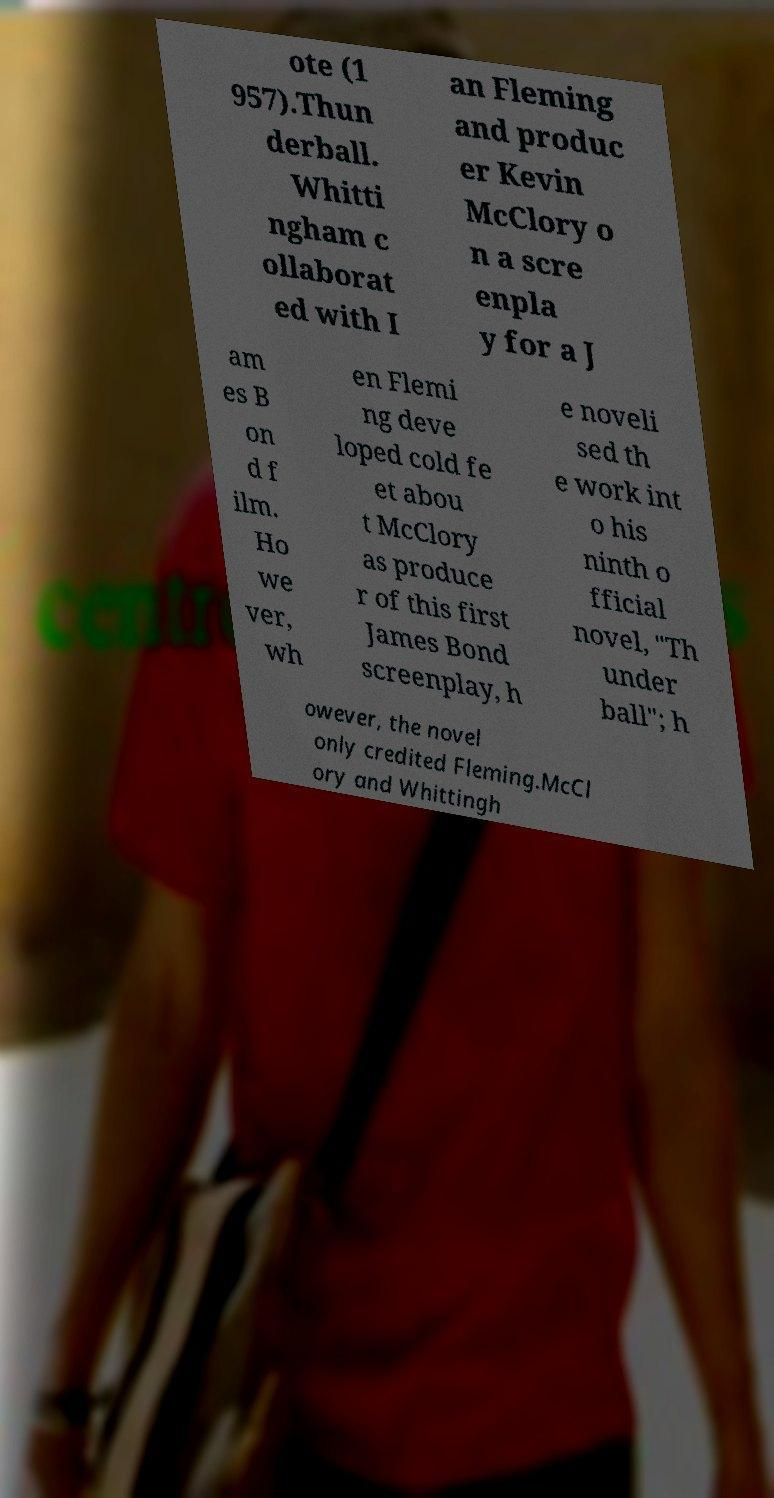Please identify and transcribe the text found in this image. ote (1 957).Thun derball. Whitti ngham c ollaborat ed with I an Fleming and produc er Kevin McClory o n a scre enpla y for a J am es B on d f ilm. Ho we ver, wh en Flemi ng deve loped cold fe et abou t McClory as produce r of this first James Bond screenplay, h e noveli sed th e work int o his ninth o fficial novel, "Th under ball"; h owever, the novel only credited Fleming.McCl ory and Whittingh 